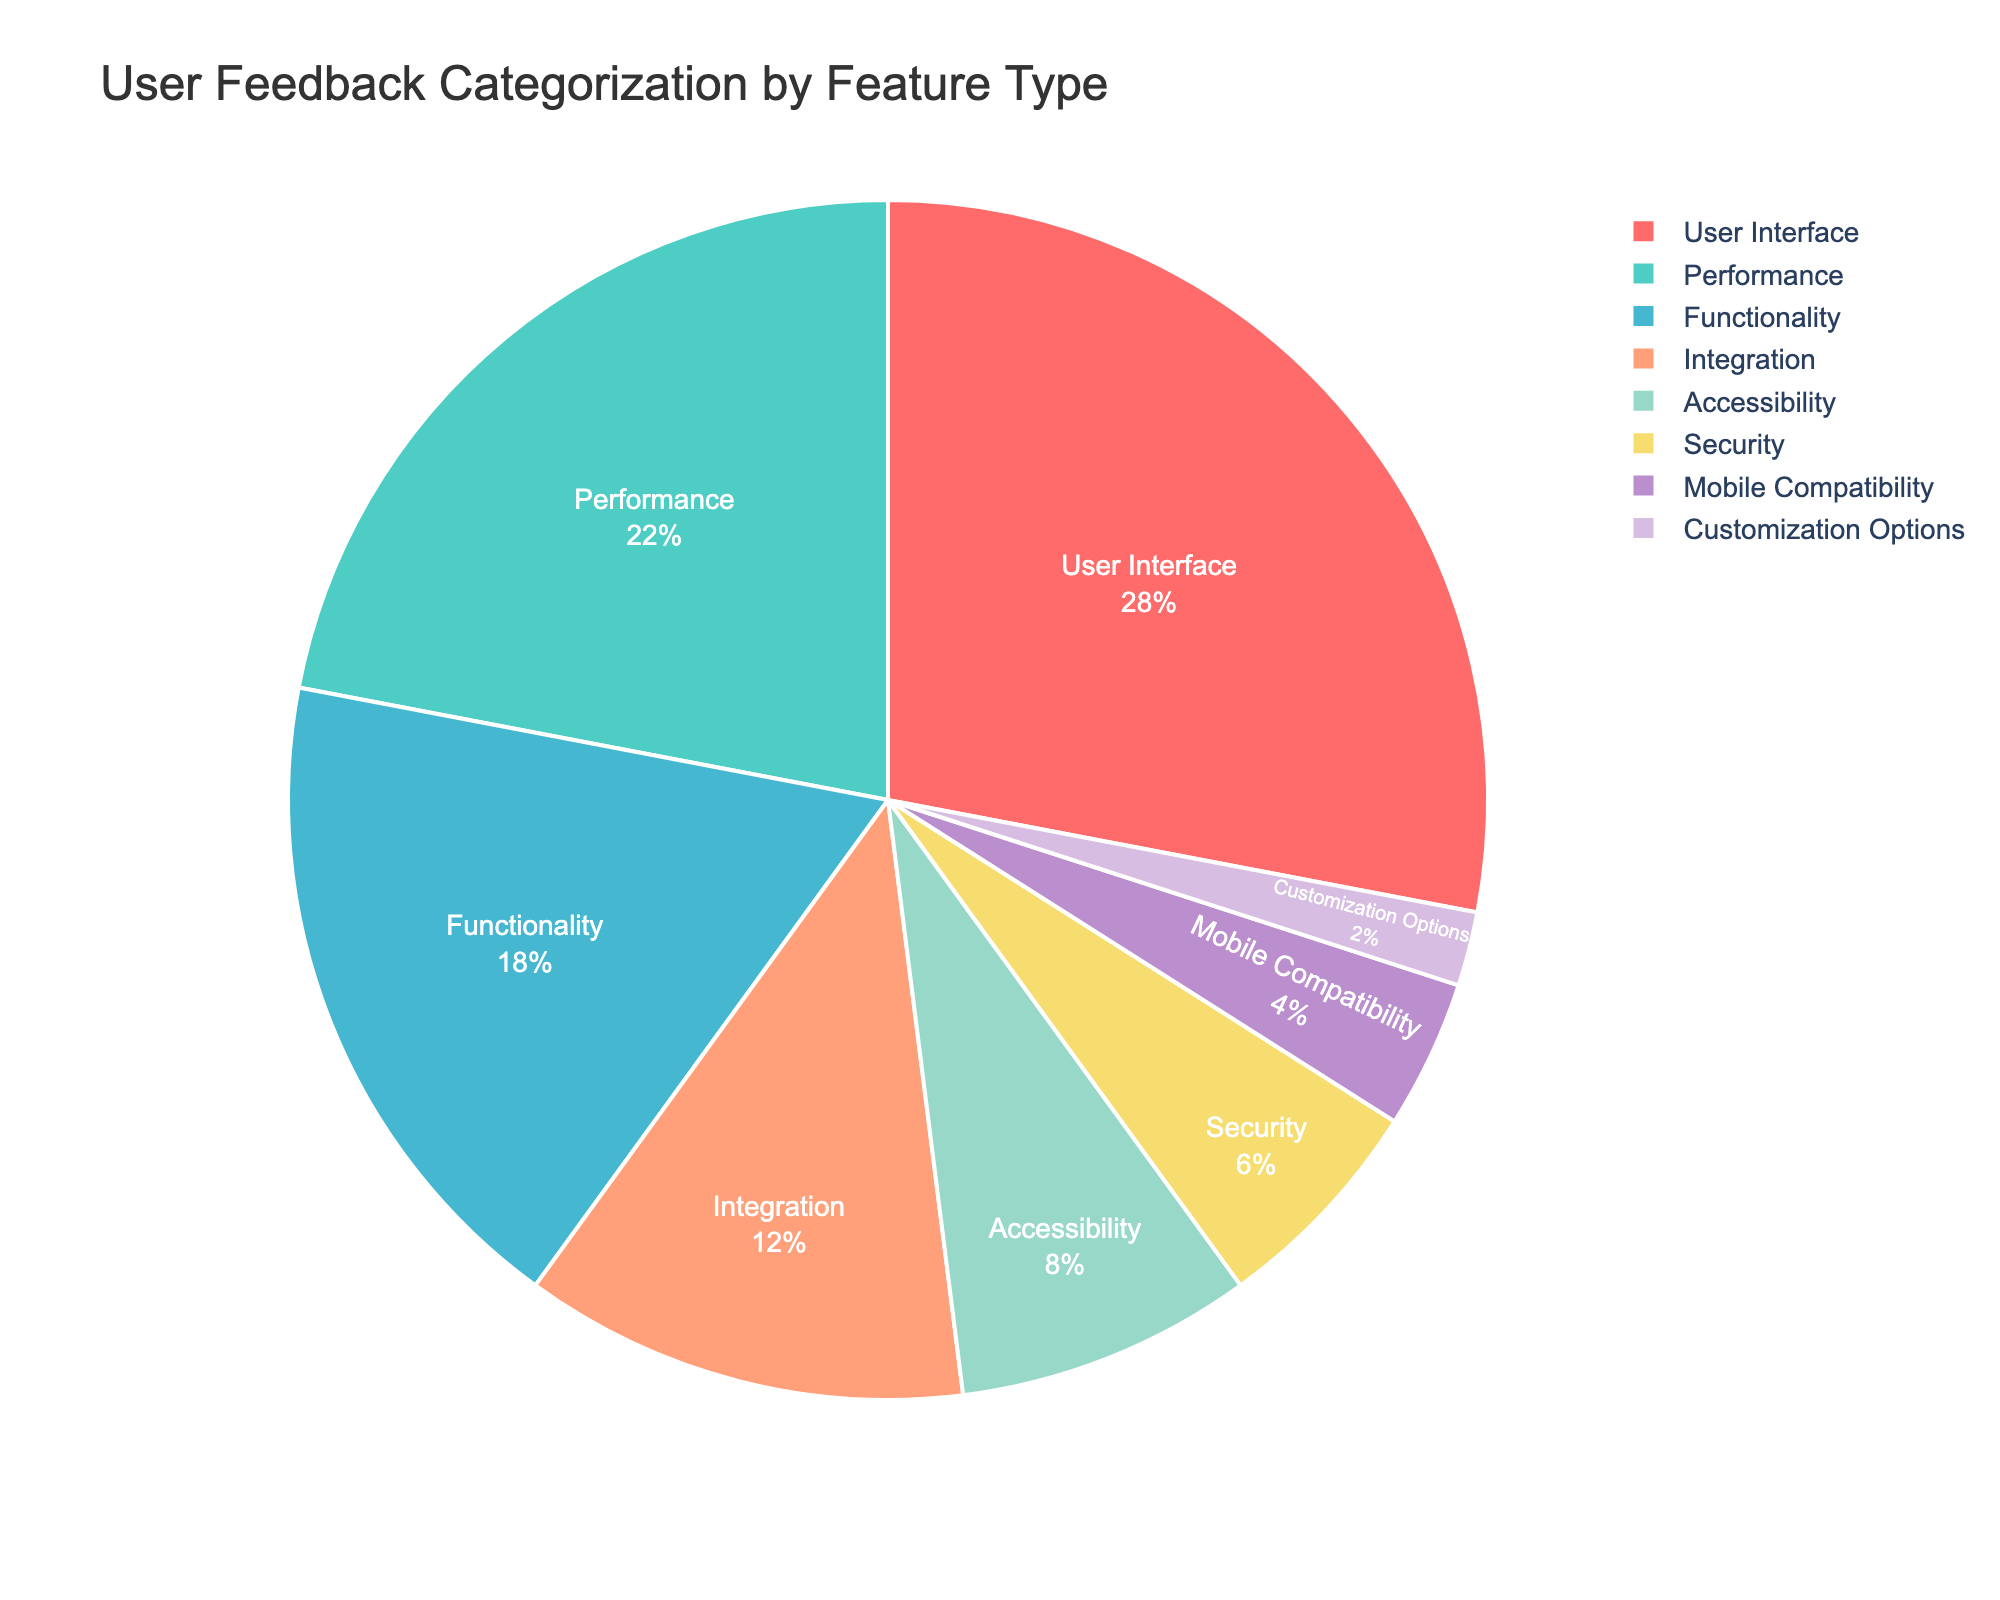what percentage of feedback is related to UI and Performance combined? We need to add the percentages of feedback related to User Interface and Performance. User Interface has 28% and Performance has 22%. 28 + 22 = 50
Answer: 50% Which feature type received the least feedback? Look for the smallest percentage in the pie chart. Customization Options has the smallest percentage at 2%.
Answer: Customization Options Is the feedback for Accessibility greater than the feedback for Security? Compare the percentages of Accessibility and Security. Accessibility has 8% while Security has 6%. Since 8% > 6%, Accessibility has more feedback.
Answer: Yes What's the total percentage of feedback for Integration and Mobile Compatibility combined? Add the percentages for Integration (12%) and Mobile Compatibility (4%). 12 + 4 = 16
Answer: 16% How much more feedback does Functionality receive compared to Customization Options? Subtract the percentage of Customization Options from Functionality. Functionality has 18% and Customization Options has 2%. 18 - 2 = 16
Answer: 16% Which feature type has the second highest percentage of feedback? Look for the second largest percentage after the highest one (User Interface - 28%). Performance has 22%, which is the second highest.
Answer: Performance By how much does Mobile Compatibility feedback fall short of Performance feedback? Subtract the percentage of Mobile Compatibility from Performance. Performance has 22% and Mobile Compatibility has 4%. 22 - 4 = 18
Answer: 18% Which feature types have less than 10% of the feedback each? Look at the percentages for each feature type and identify those with less than 10%. These are Accessibility (8%), Security (6%), Mobile Compatibility (4%), and Customization Options (2%).
Answer: Accessibility, Security, Mobile Compatibility, Customization Options What percentage of feedback is not related to User Interface? Subtract the percentage of User Interface feedback from 100%. User Interface is 28%, so 100 - 28 = 72
Answer: 72% Among Functionality, Integration, and Security, which has the highest percentage of feedback? Compare the percentages of Functionality (18%), Integration (12%), and Security (6%). Functionality has the highest percentage.
Answer: Functionality 